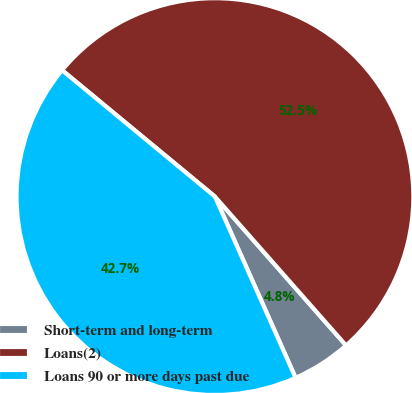<chart> <loc_0><loc_0><loc_500><loc_500><pie_chart><fcel>Short-term and long-term<fcel>Loans(2)<fcel>Loans 90 or more days past due<nl><fcel>4.83%<fcel>52.51%<fcel>42.66%<nl></chart> 